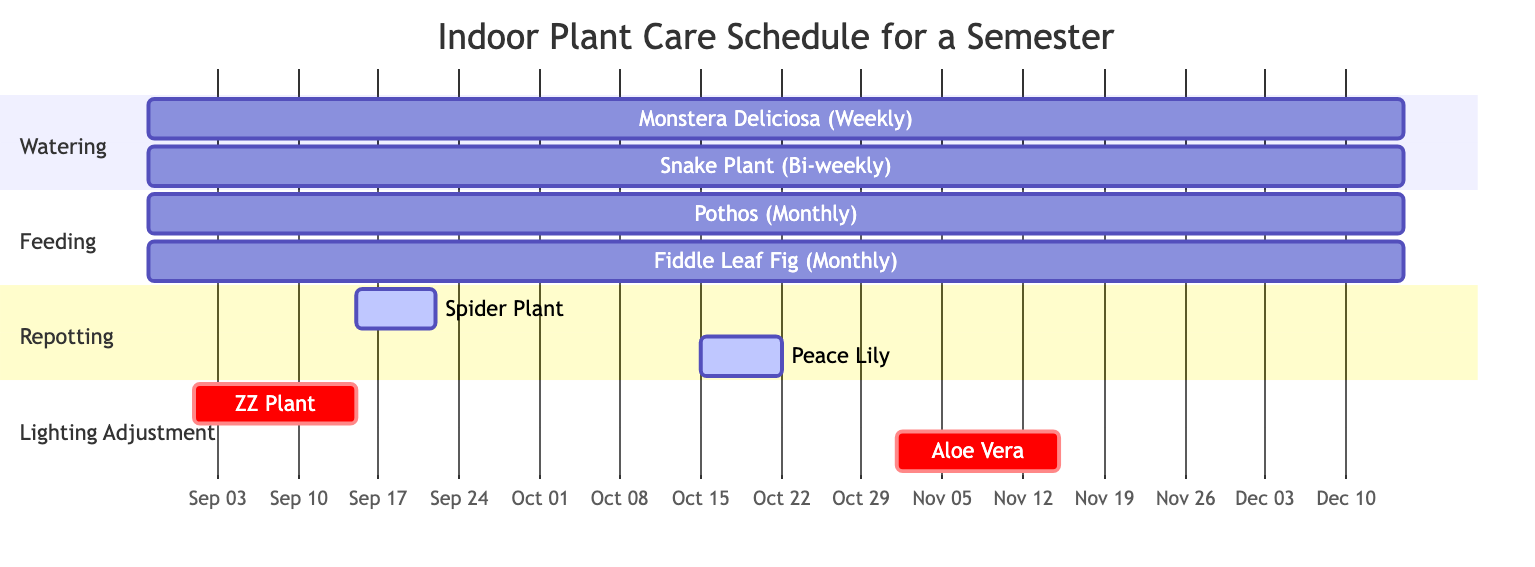What task is scheduled for the Snake Plant? The Snake Plant has the task of watering scheduled on a bi-weekly frequency, which is displayed in the watering section of the Gantt chart.
Answer: Watering How many weeks is the Monstera Deliciosa scheduled for watering? The Monstera Deliciosa is scheduled for watering for a total of 16 weeks, as indicated by the timeline from August 28th to December 15th along with the specified duration.
Answer: 16 weeks When is the repotting for the Peace Lily scheduled? The repotting task for the Peace Lily is scheduled to occur starting on October 15th for one week, as shown in the repotting section of the Gantt chart.
Answer: October 15th Which plant has a seasonal lighting adjustment, and when is it scheduled? The Aloe Vera plant has a seasonal lighting adjustment scheduled for November 1st, lasting for two weeks as indicated in the lighting adjustment section.
Answer: Aloe Vera, November 1st How many lighting adjustments are scheduled in total? There are two lighting adjustment tasks scheduled: one for the ZZ Plant and another for the Aloe Vera, both reflected in the lighting adjustment section of the chart.
Answer: 2 